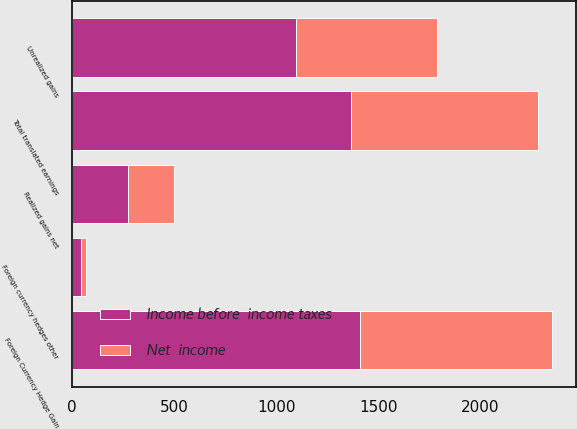<chart> <loc_0><loc_0><loc_500><loc_500><stacked_bar_chart><ecel><fcel>Realized gains net<fcel>Unrealized gains<fcel>Total translated earnings<fcel>Foreign currency hedges other<fcel>Foreign Currency Hedge Gain<nl><fcel>Income before  income taxes<fcel>274<fcel>1095<fcel>1369<fcel>42<fcel>1411<nl><fcel>Net  income<fcel>224<fcel>692<fcel>916<fcel>27<fcel>943<nl></chart> 